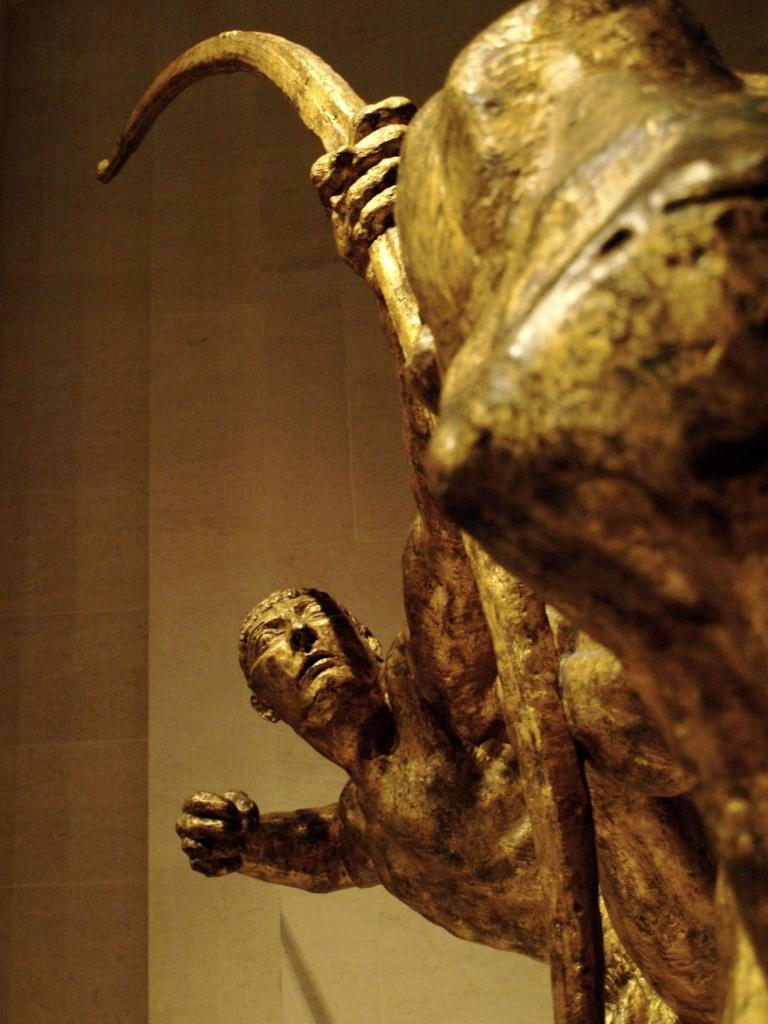What is the main subject of the picture? The main subject of the picture is a sculpture. What does the sculpture depict? The sculpture depicts a person. What is the person in the sculpture holding? The person is holding an archer in their hands. What type of development is taking place in the background of the image? There is no development or background visible in the image; it only features a sculpture. Can you tell me how many owls are perched on the person's shoulder in the sculpture? There are no owls present in the image; the person is holding an archer. 